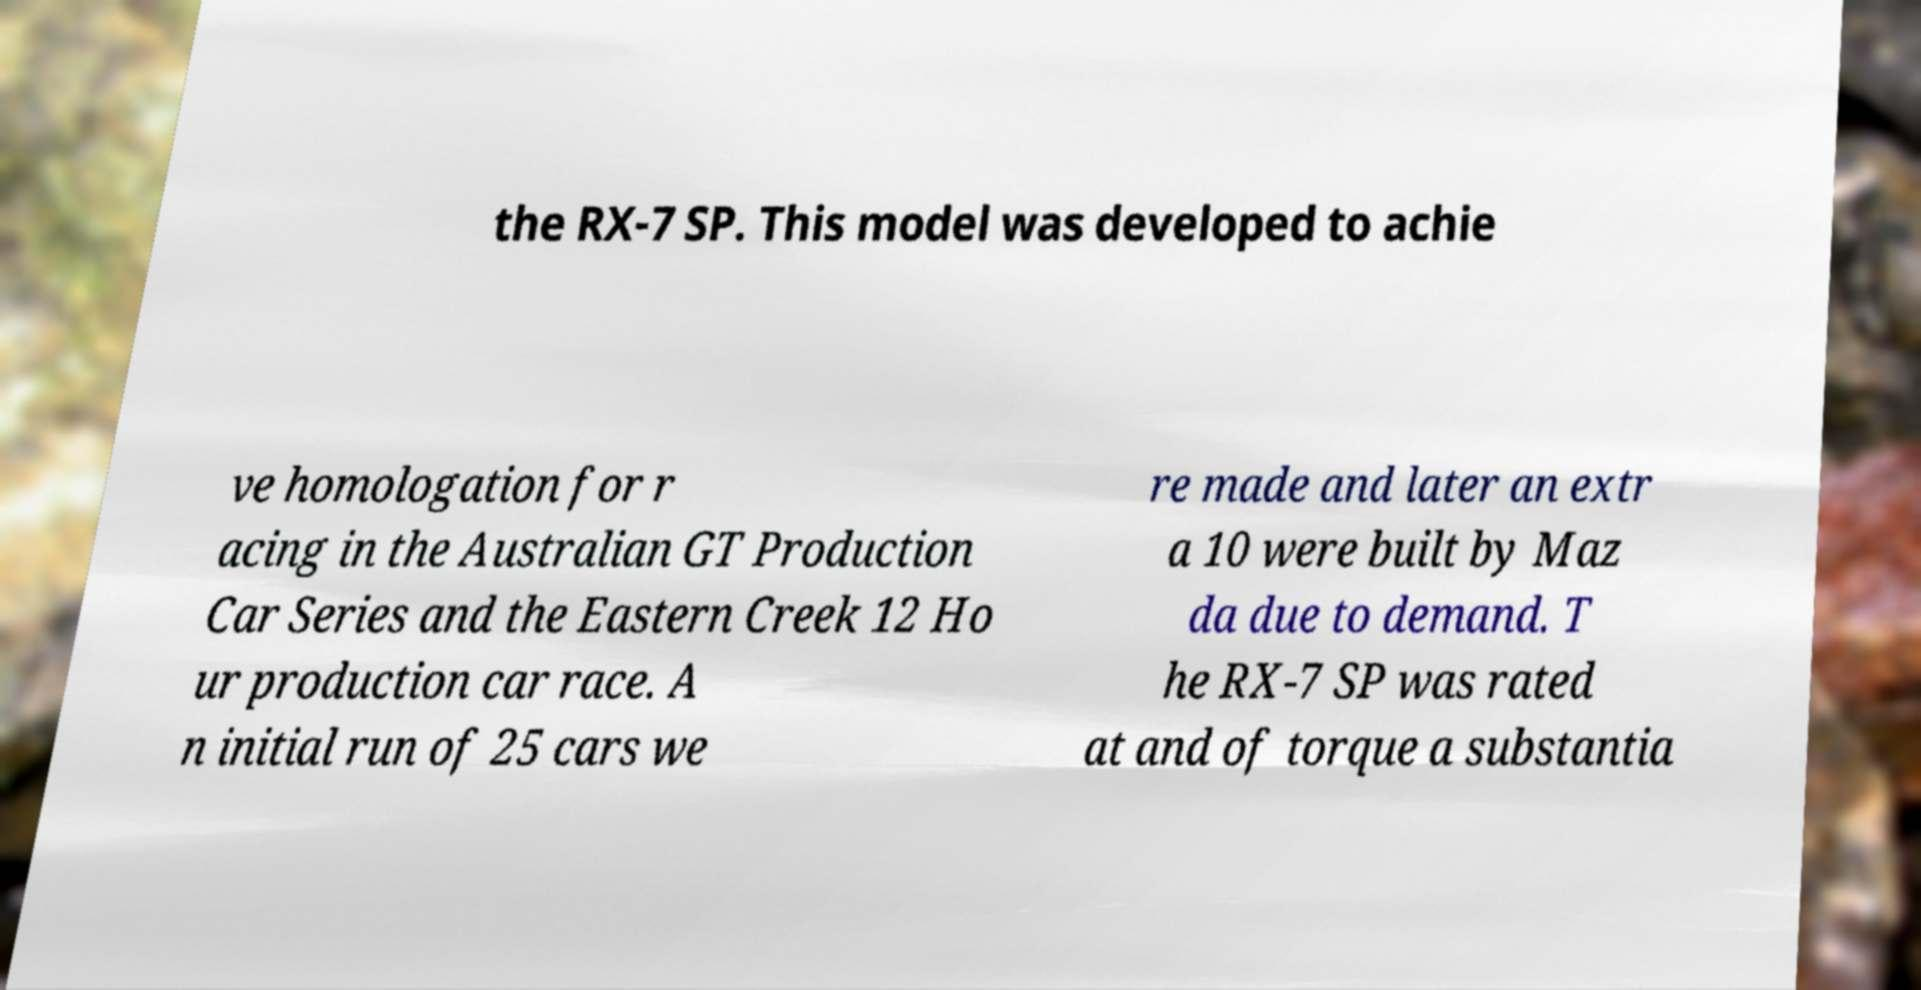Can you read and provide the text displayed in the image?This photo seems to have some interesting text. Can you extract and type it out for me? the RX-7 SP. This model was developed to achie ve homologation for r acing in the Australian GT Production Car Series and the Eastern Creek 12 Ho ur production car race. A n initial run of 25 cars we re made and later an extr a 10 were built by Maz da due to demand. T he RX-7 SP was rated at and of torque a substantia 